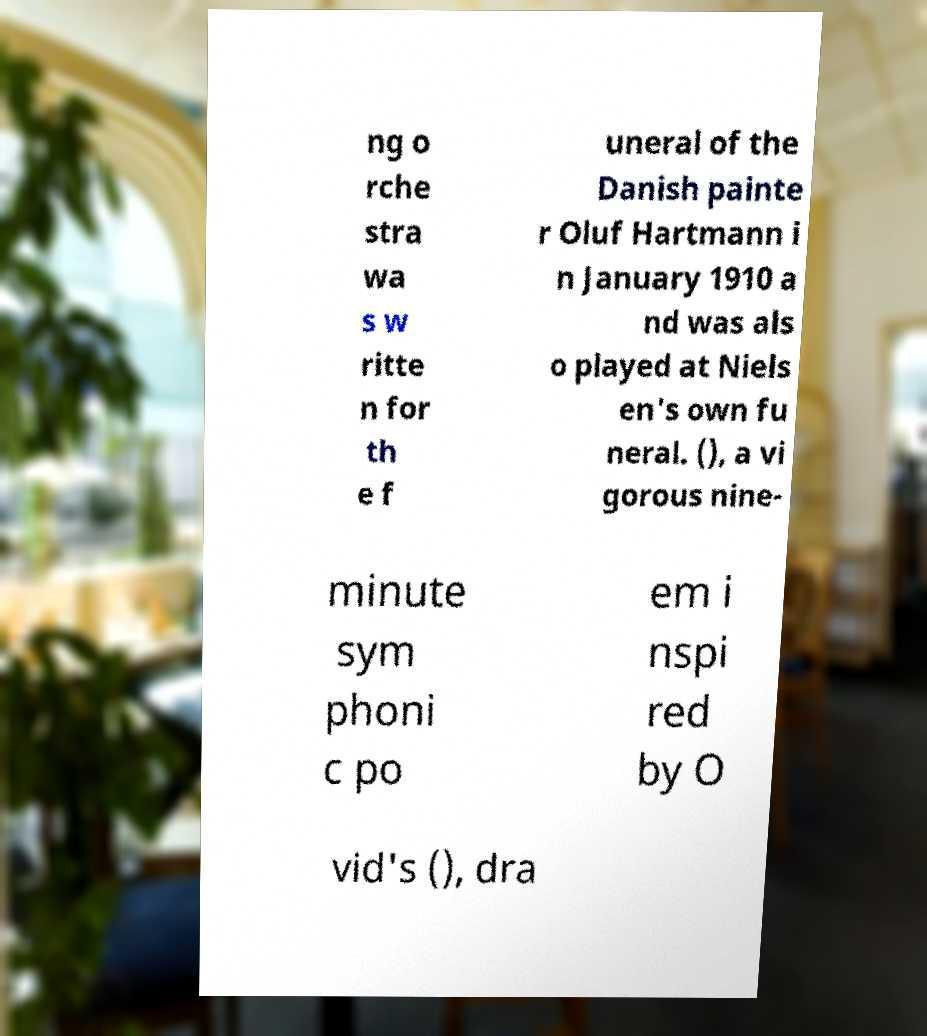Please identify and transcribe the text found in this image. ng o rche stra wa s w ritte n for th e f uneral of the Danish painte r Oluf Hartmann i n January 1910 a nd was als o played at Niels en's own fu neral. (), a vi gorous nine- minute sym phoni c po em i nspi red by O vid's (), dra 